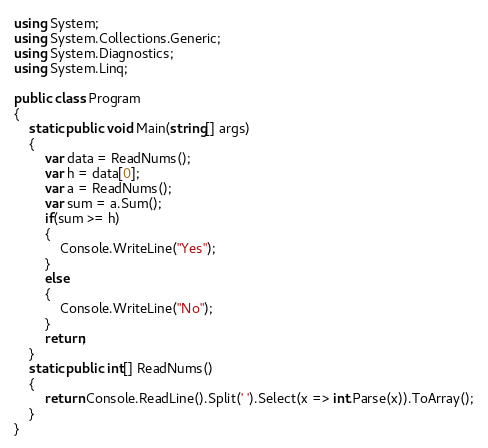Convert code to text. <code><loc_0><loc_0><loc_500><loc_500><_C#_>using System;
using System.Collections.Generic;
using System.Diagnostics;
using System.Linq;

public class Program
{
	static public void Main(string[] args)
	{
		var data = ReadNums();
		var h = data[0];
		var a = ReadNums();
		var sum = a.Sum();
		if(sum >= h)
		{
			Console.WriteLine("Yes");
		}
		else
		{
			Console.WriteLine("No");
		}
		return;
	}
	static public int[] ReadNums()
	{
		return Console.ReadLine().Split(' ').Select(x => int.Parse(x)).ToArray();
	}
}</code> 